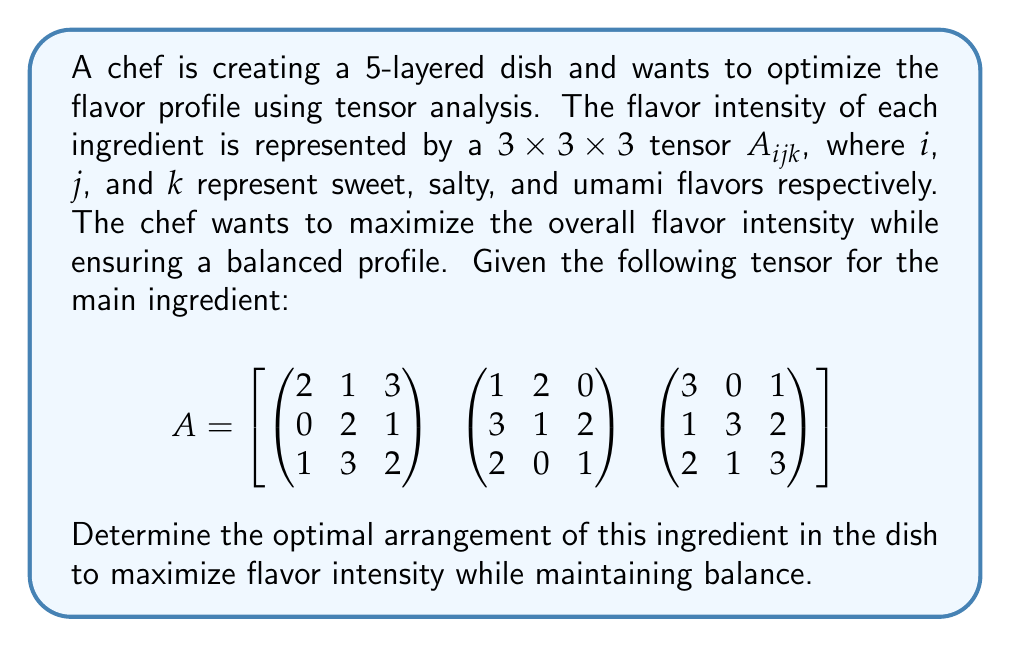Show me your answer to this math problem. To solve this problem, we'll follow these steps:

1) First, we need to understand what the tensor represents. Each element $A_{ijk}$ represents the flavor intensity for a combination of sweet (i), salty (j), and umami (k) flavors.

2) To maximize flavor intensity while maintaining balance, we want to find the arrangement that gives the highest sum of elements while keeping the sum of each flavor dimension roughly equal.

3) Let's calculate the sum along each dimension:

   Sweet (i): 
   $$\sum_{j,k} A_{1jk} = 16, \sum_{j,k} A_{2jk} = 15, \sum_{j,k} A_{3jk} = 18$$

   Salty (j):
   $$\sum_{i,k} A_{i1k} = 15, \sum_{i,k} A_{i2k} = 16, \sum_{i,k} A_{i3k} = 18$$

   Umami (k):
   $$\sum_{i,j} A_{ij1} = 15, \sum_{i,j} A_{ij2} = 16, \sum_{i,j} A_{ij3} = 18$$

4) We can see that the third index in each dimension gives the highest sum (18). This suggests that the optimal arrangement should emphasize these elements.

5) The optimal arrangement would be to place the ingredient in a way that maximizes the $(3,3,3)$ element, which has a value of 3.

6) To maintain balance, we should also consider the next highest values in each dimension, which are the $(1,3,3)$ and $(3,1,3)$ elements, both with a value of 3.

7) Therefore, the optimal arrangement would be to place the ingredient in a way that emphasizes these three positions: $(3,3,3)$, $(1,3,3)$, and $(3,1,3)$.

8) This arrangement gives a total flavor intensity of $3 + 3 + 3 = 9$ while maintaining a good balance across all three flavor dimensions.
Answer: Emphasize positions $(3,3,3)$, $(1,3,3)$, and $(3,1,3)$ in the tensor. 